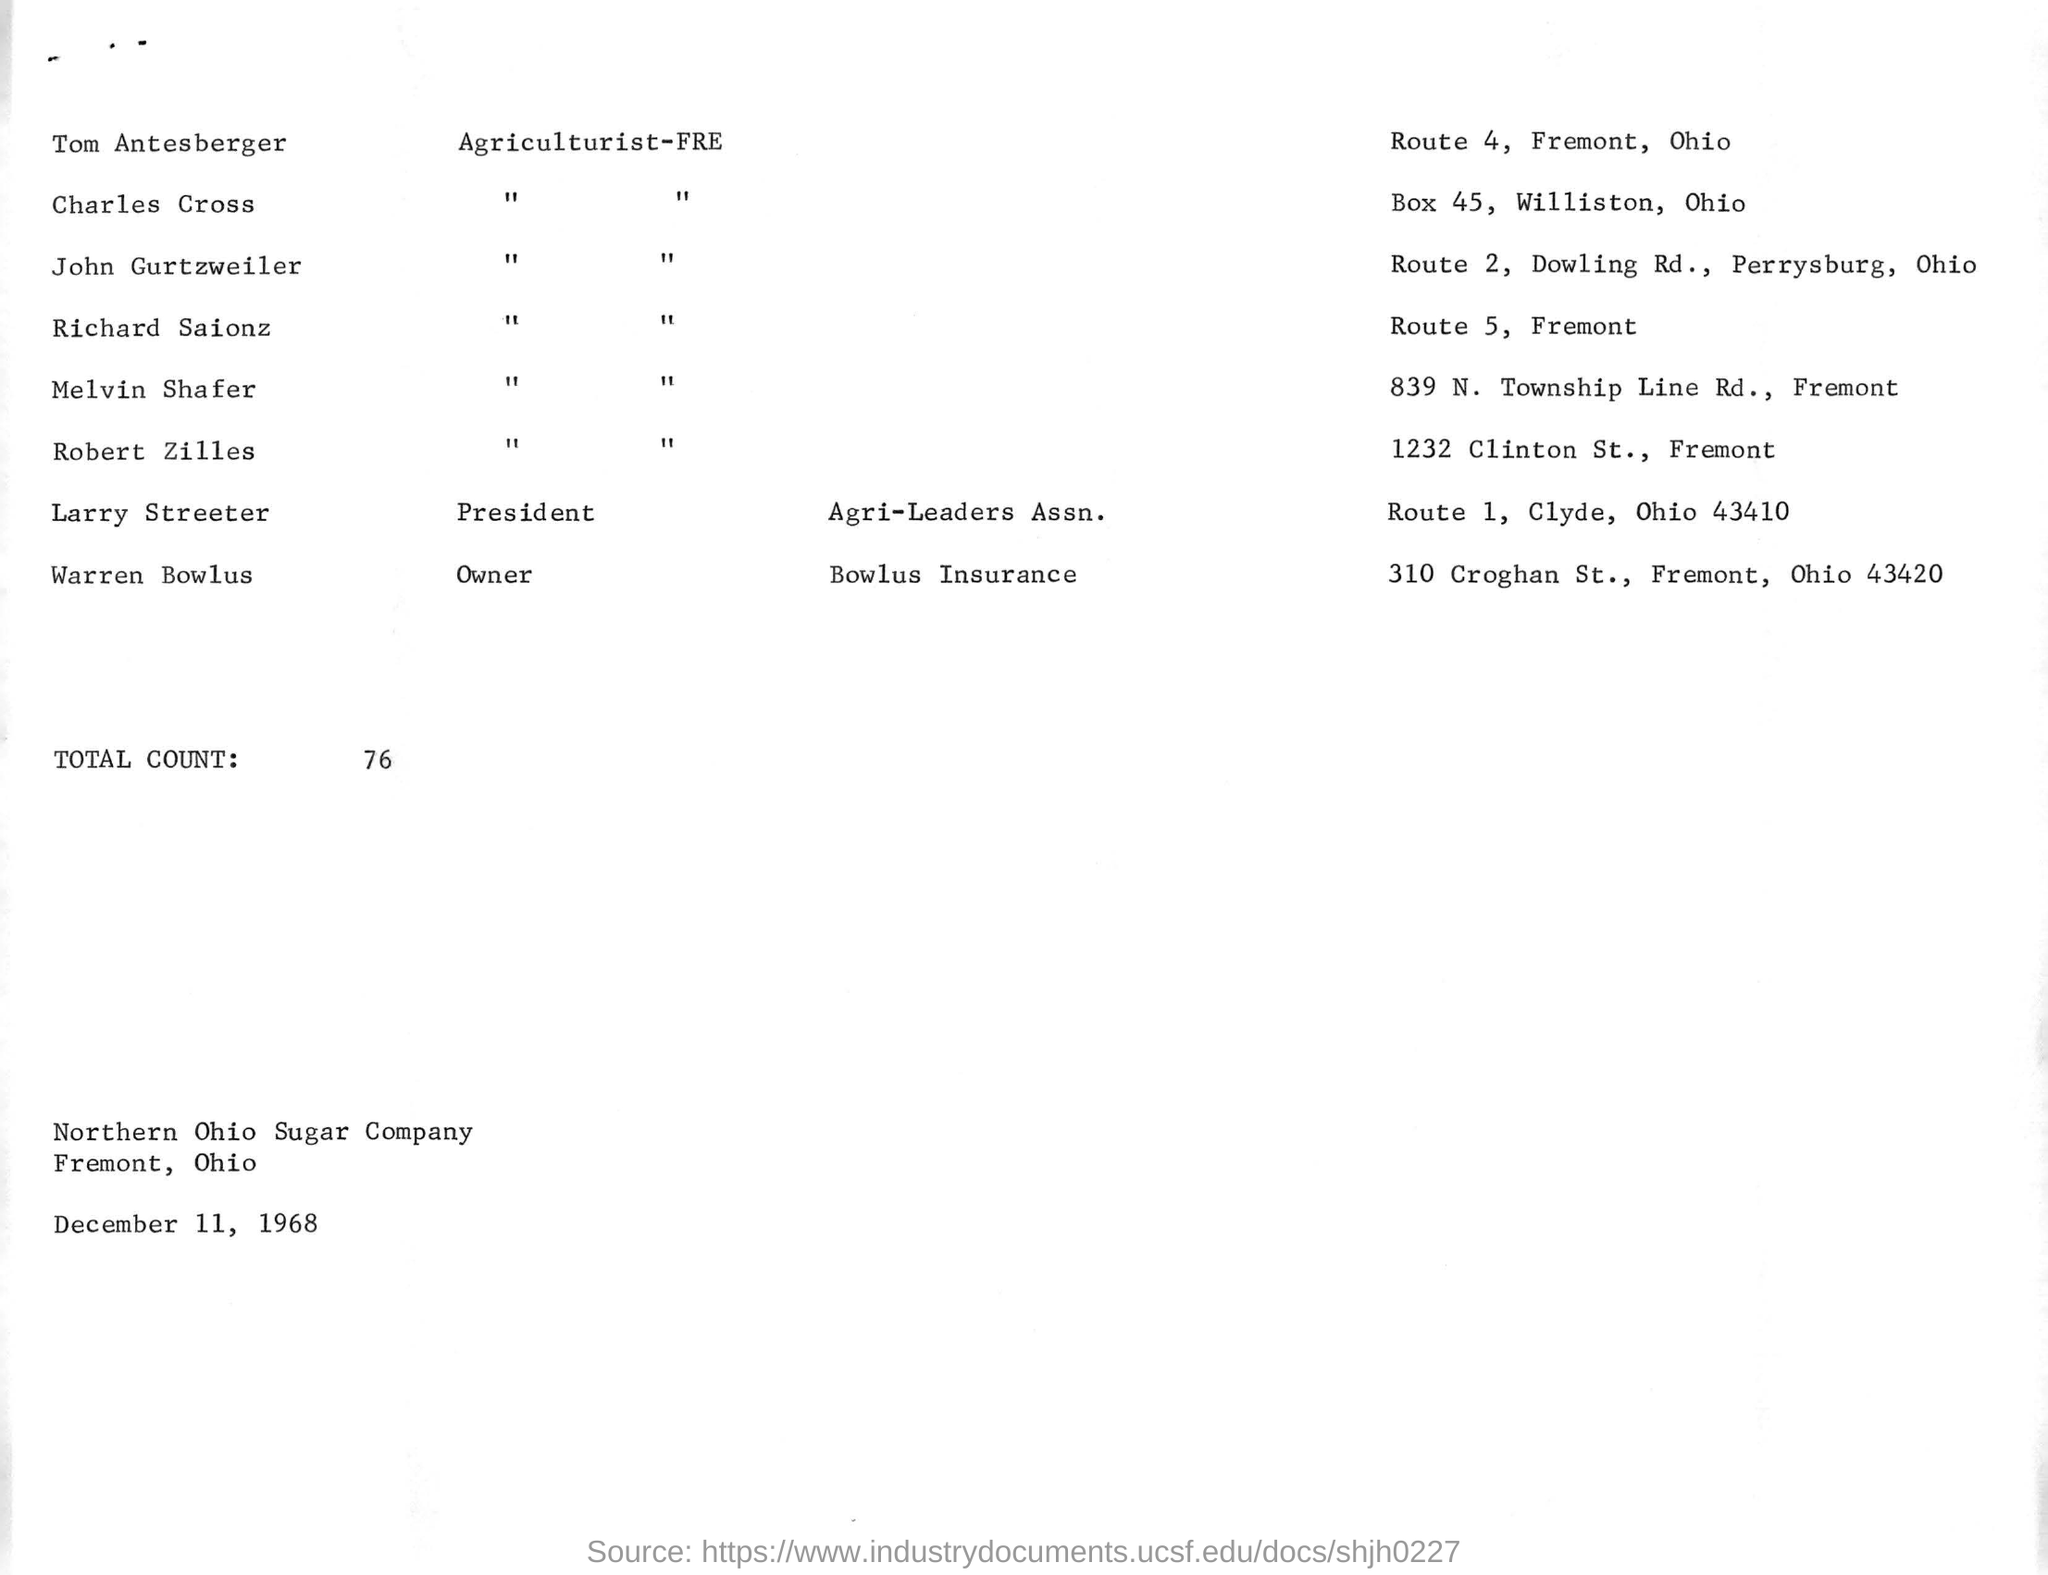Identify some key points in this picture. The specified route number for Thomas Antesberger is 4. What is the total count mentioned to be 76? The route number mentioned for Richard Saionz is 5. The Northern Ohio Sugar Company is named. The date mentioned in the given page is December 11, 1968. 